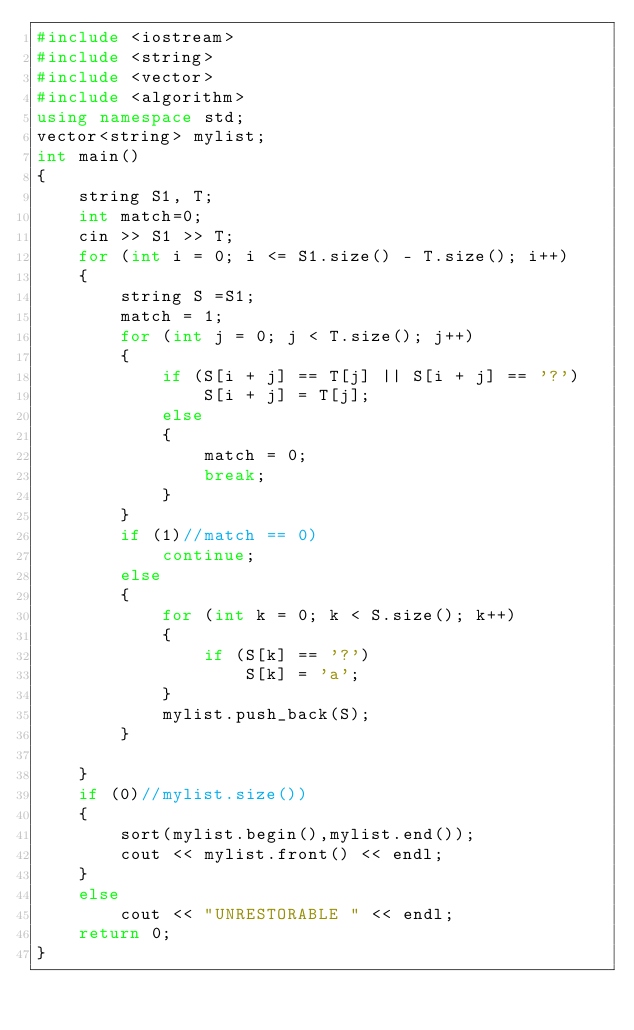<code> <loc_0><loc_0><loc_500><loc_500><_C++_>#include <iostream>
#include <string>
#include <vector>
#include <algorithm>
using namespace std;
vector<string> mylist;
int main()
{
	string S1, T;
	int match=0;
	cin >> S1 >> T;
	for (int i = 0; i <= S1.size() - T.size(); i++)
	{
		string S =S1;
		match = 1;
		for (int j = 0; j < T.size(); j++)
		{
			if (S[i + j] == T[j] || S[i + j] == '?')
				S[i + j] = T[j];
			else
			{
				match = 0;
				break;
			}
		}
		if (1)//match == 0)
			continue;
		else
		{
			for (int k = 0; k < S.size(); k++)
			{
				if (S[k] == '?')
					S[k] = 'a';
			}
			mylist.push_back(S);
		}

	}
	if (0)//mylist.size())
	{
		sort(mylist.begin(),mylist.end());
		cout << mylist.front() << endl;
	}
	else
		cout << "UNRESTORABLE " << endl;
	return 0;
}</code> 